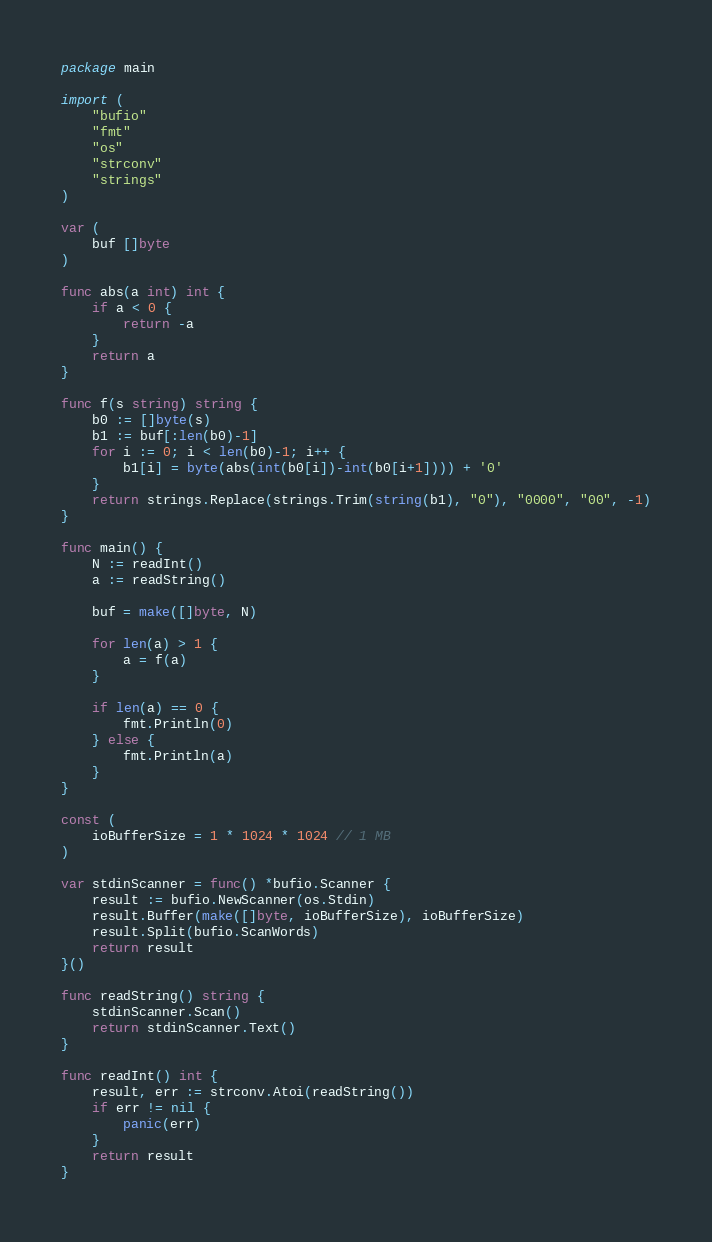Convert code to text. <code><loc_0><loc_0><loc_500><loc_500><_Go_>package main

import (
	"bufio"
	"fmt"
	"os"
	"strconv"
	"strings"
)

var (
	buf []byte
)

func abs(a int) int {
	if a < 0 {
		return -a
	}
	return a
}

func f(s string) string {
	b0 := []byte(s)
	b1 := buf[:len(b0)-1]
	for i := 0; i < len(b0)-1; i++ {
		b1[i] = byte(abs(int(b0[i])-int(b0[i+1]))) + '0'
	}
	return strings.Replace(strings.Trim(string(b1), "0"), "0000", "00", -1)
}

func main() {
	N := readInt()
	a := readString()

	buf = make([]byte, N)

	for len(a) > 1 {
		a = f(a)
	}

	if len(a) == 0 {
		fmt.Println(0)
	} else {
		fmt.Println(a)
	}
}

const (
	ioBufferSize = 1 * 1024 * 1024 // 1 MB
)

var stdinScanner = func() *bufio.Scanner {
	result := bufio.NewScanner(os.Stdin)
	result.Buffer(make([]byte, ioBufferSize), ioBufferSize)
	result.Split(bufio.ScanWords)
	return result
}()

func readString() string {
	stdinScanner.Scan()
	return stdinScanner.Text()
}

func readInt() int {
	result, err := strconv.Atoi(readString())
	if err != nil {
		panic(err)
	}
	return result
}
</code> 